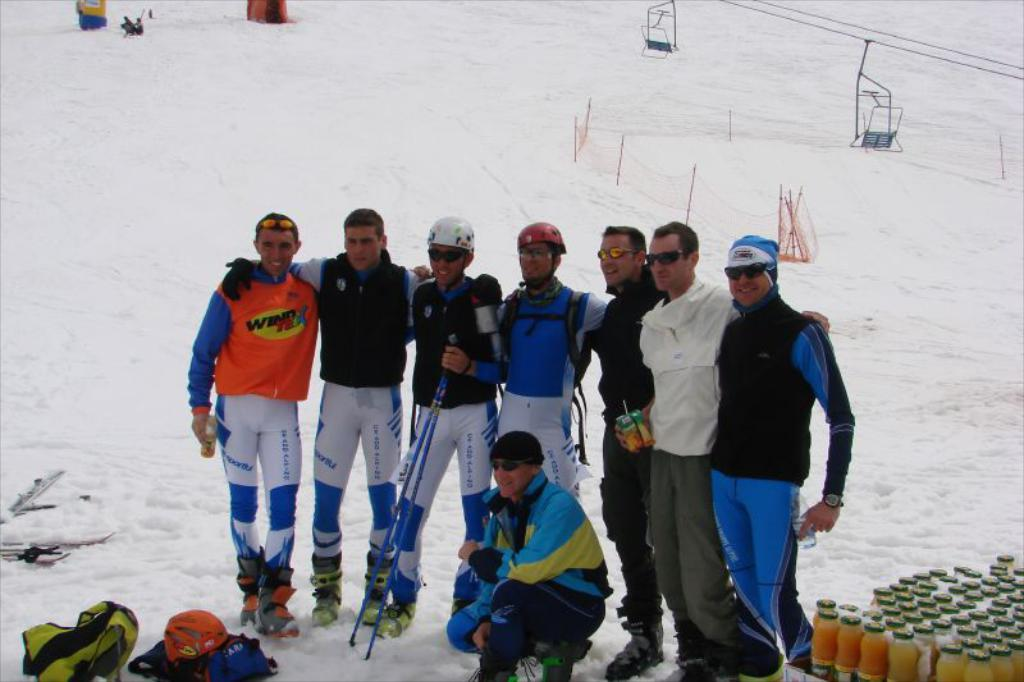What is happening in the image? There are people standing in the image. What can be seen in the background of the image? There is a fence, bottles, and bags in the background of the image. Are there any other objects visible in the background? Yes, there are other objects in the background of the image. What type of shock can be seen affecting the people in the image? There is no shock present in the image; the people are simply standing. What is the scale of the downtown area visible in the image? There is no downtown area visible in the image; it only shows people standing and objects in the background. 